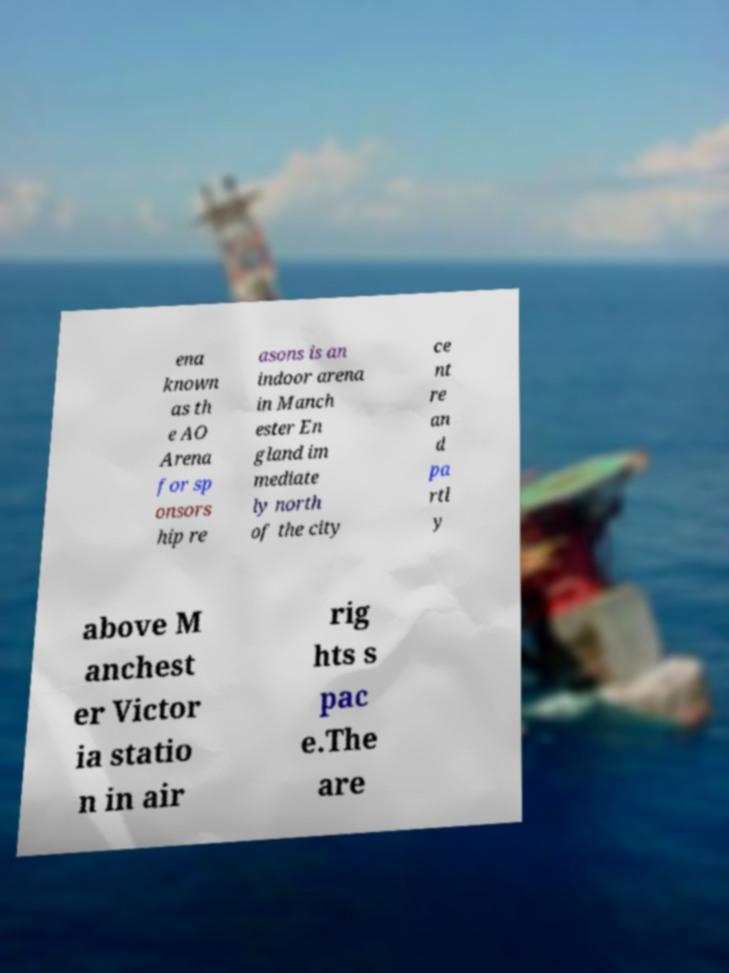Could you extract and type out the text from this image? ena known as th e AO Arena for sp onsors hip re asons is an indoor arena in Manch ester En gland im mediate ly north of the city ce nt re an d pa rtl y above M anchest er Victor ia statio n in air rig hts s pac e.The are 